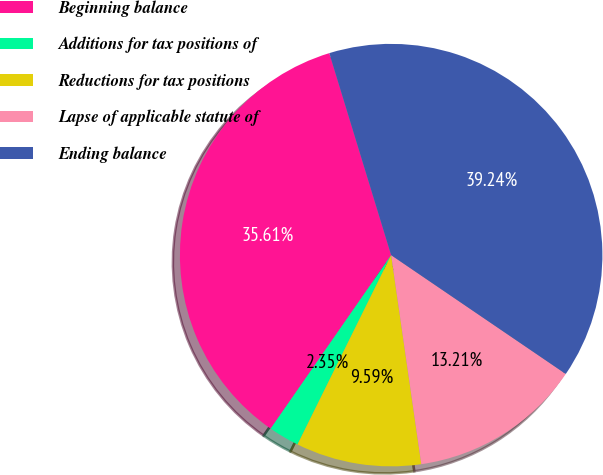<chart> <loc_0><loc_0><loc_500><loc_500><pie_chart><fcel>Beginning balance<fcel>Additions for tax positions of<fcel>Reductions for tax positions<fcel>Lapse of applicable statute of<fcel>Ending balance<nl><fcel>35.61%<fcel>2.35%<fcel>9.59%<fcel>13.21%<fcel>39.24%<nl></chart> 